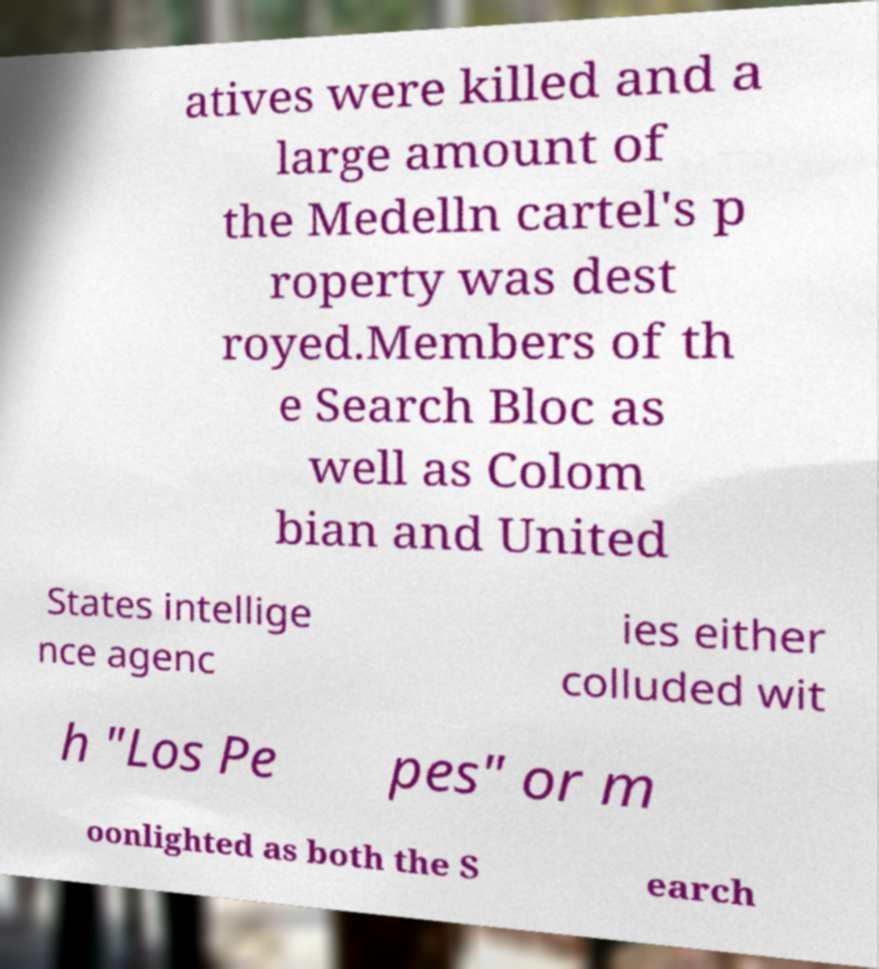Could you assist in decoding the text presented in this image and type it out clearly? atives were killed and a large amount of the Medelln cartel's p roperty was dest royed.Members of th e Search Bloc as well as Colom bian and United States intellige nce agenc ies either colluded wit h "Los Pe pes" or m oonlighted as both the S earch 